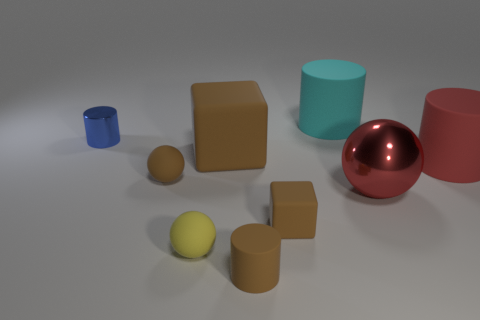Subtract all tiny spheres. How many spheres are left? 1 Subtract all red cylinders. How many cylinders are left? 3 Subtract all cylinders. How many objects are left? 5 Subtract 1 blocks. How many blocks are left? 1 Subtract all brown cylinders. Subtract all tiny red blocks. How many objects are left? 8 Add 2 metallic cylinders. How many metallic cylinders are left? 3 Add 5 tiny brown matte blocks. How many tiny brown matte blocks exist? 6 Subtract 0 gray cylinders. How many objects are left? 9 Subtract all red cubes. Subtract all purple cylinders. How many cubes are left? 2 Subtract all yellow cylinders. How many yellow balls are left? 1 